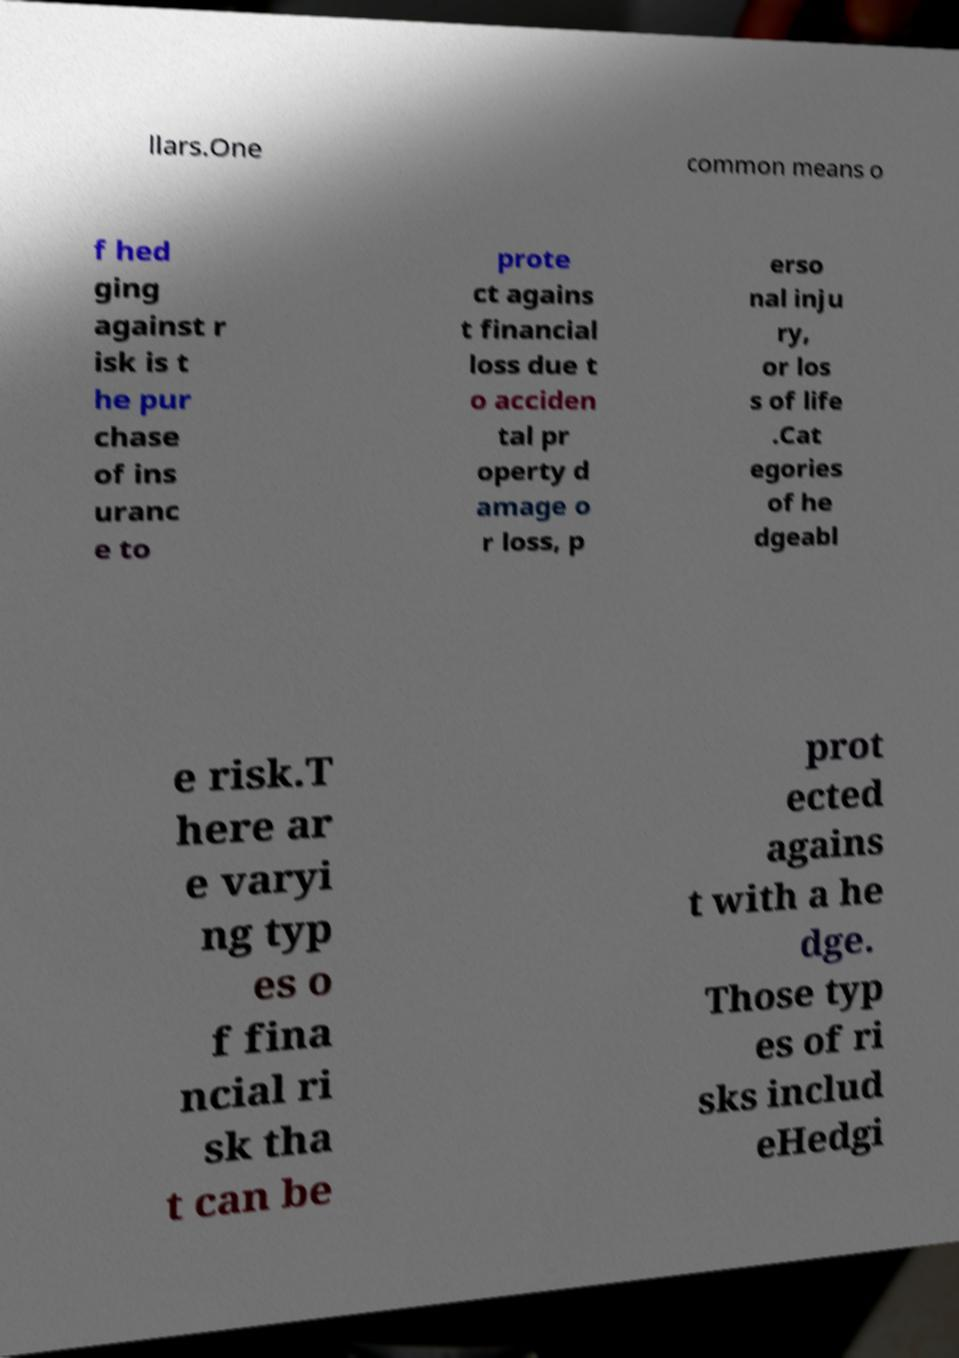Can you accurately transcribe the text from the provided image for me? llars.One common means o f hed ging against r isk is t he pur chase of ins uranc e to prote ct agains t financial loss due t o acciden tal pr operty d amage o r loss, p erso nal inju ry, or los s of life .Cat egories of he dgeabl e risk.T here ar e varyi ng typ es o f fina ncial ri sk tha t can be prot ected agains t with a he dge. Those typ es of ri sks includ eHedgi 